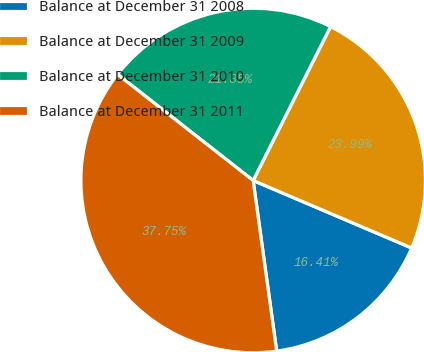<chart> <loc_0><loc_0><loc_500><loc_500><pie_chart><fcel>Balance at December 31 2008<fcel>Balance at December 31 2009<fcel>Balance at December 31 2010<fcel>Balance at December 31 2011<nl><fcel>16.41%<fcel>23.99%<fcel>21.85%<fcel>37.75%<nl></chart> 